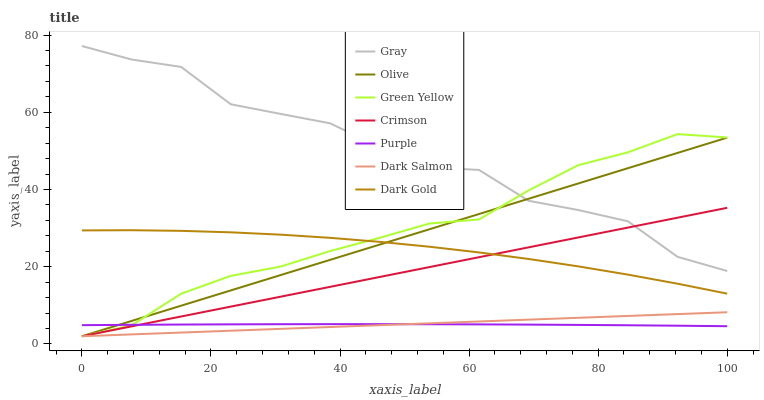Does Dark Gold have the minimum area under the curve?
Answer yes or no. No. Does Dark Gold have the maximum area under the curve?
Answer yes or no. No. Is Dark Gold the smoothest?
Answer yes or no. No. Is Dark Gold the roughest?
Answer yes or no. No. Does Dark Gold have the lowest value?
Answer yes or no. No. Does Dark Gold have the highest value?
Answer yes or no. No. Is Dark Salmon less than Dark Gold?
Answer yes or no. Yes. Is Dark Gold greater than Dark Salmon?
Answer yes or no. Yes. Does Dark Salmon intersect Dark Gold?
Answer yes or no. No. 